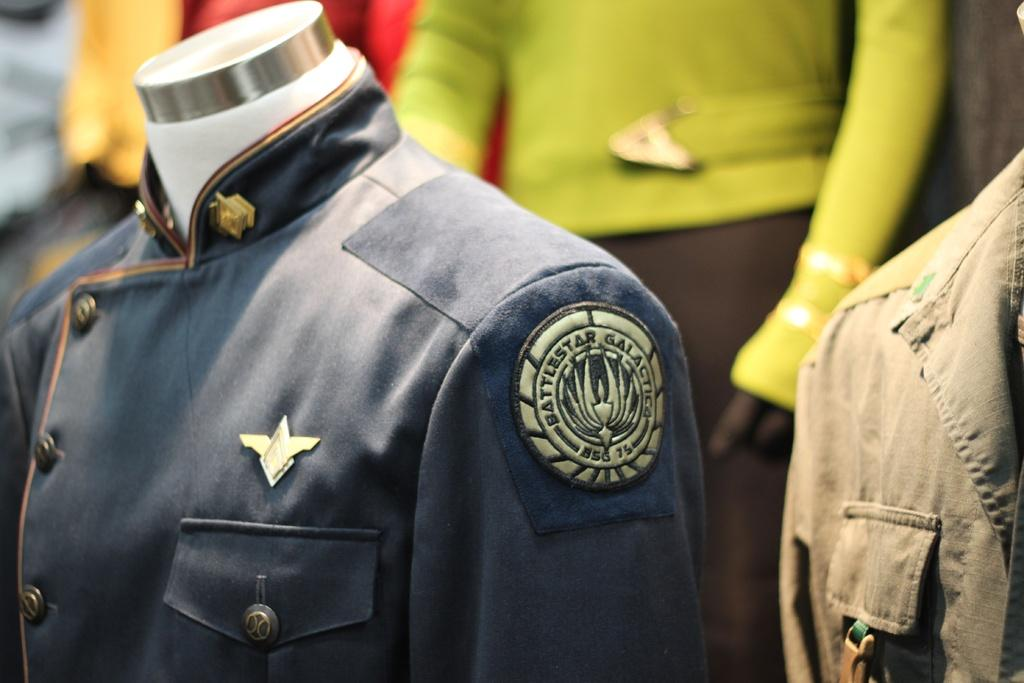What type of clothing is visible in the image? There are shirts in the image. Are there any distinguishing features on the shirts? Yes, there is an emblem on one of the shirts. Can you describe the background of the image? The background of the image is blurry. Can you tell me how many donkeys are visible in the image? There are no donkeys present in the image. What type of vehicle can be seen in the background of the image? There is no vehicle visible in the image; the background is blurry. 